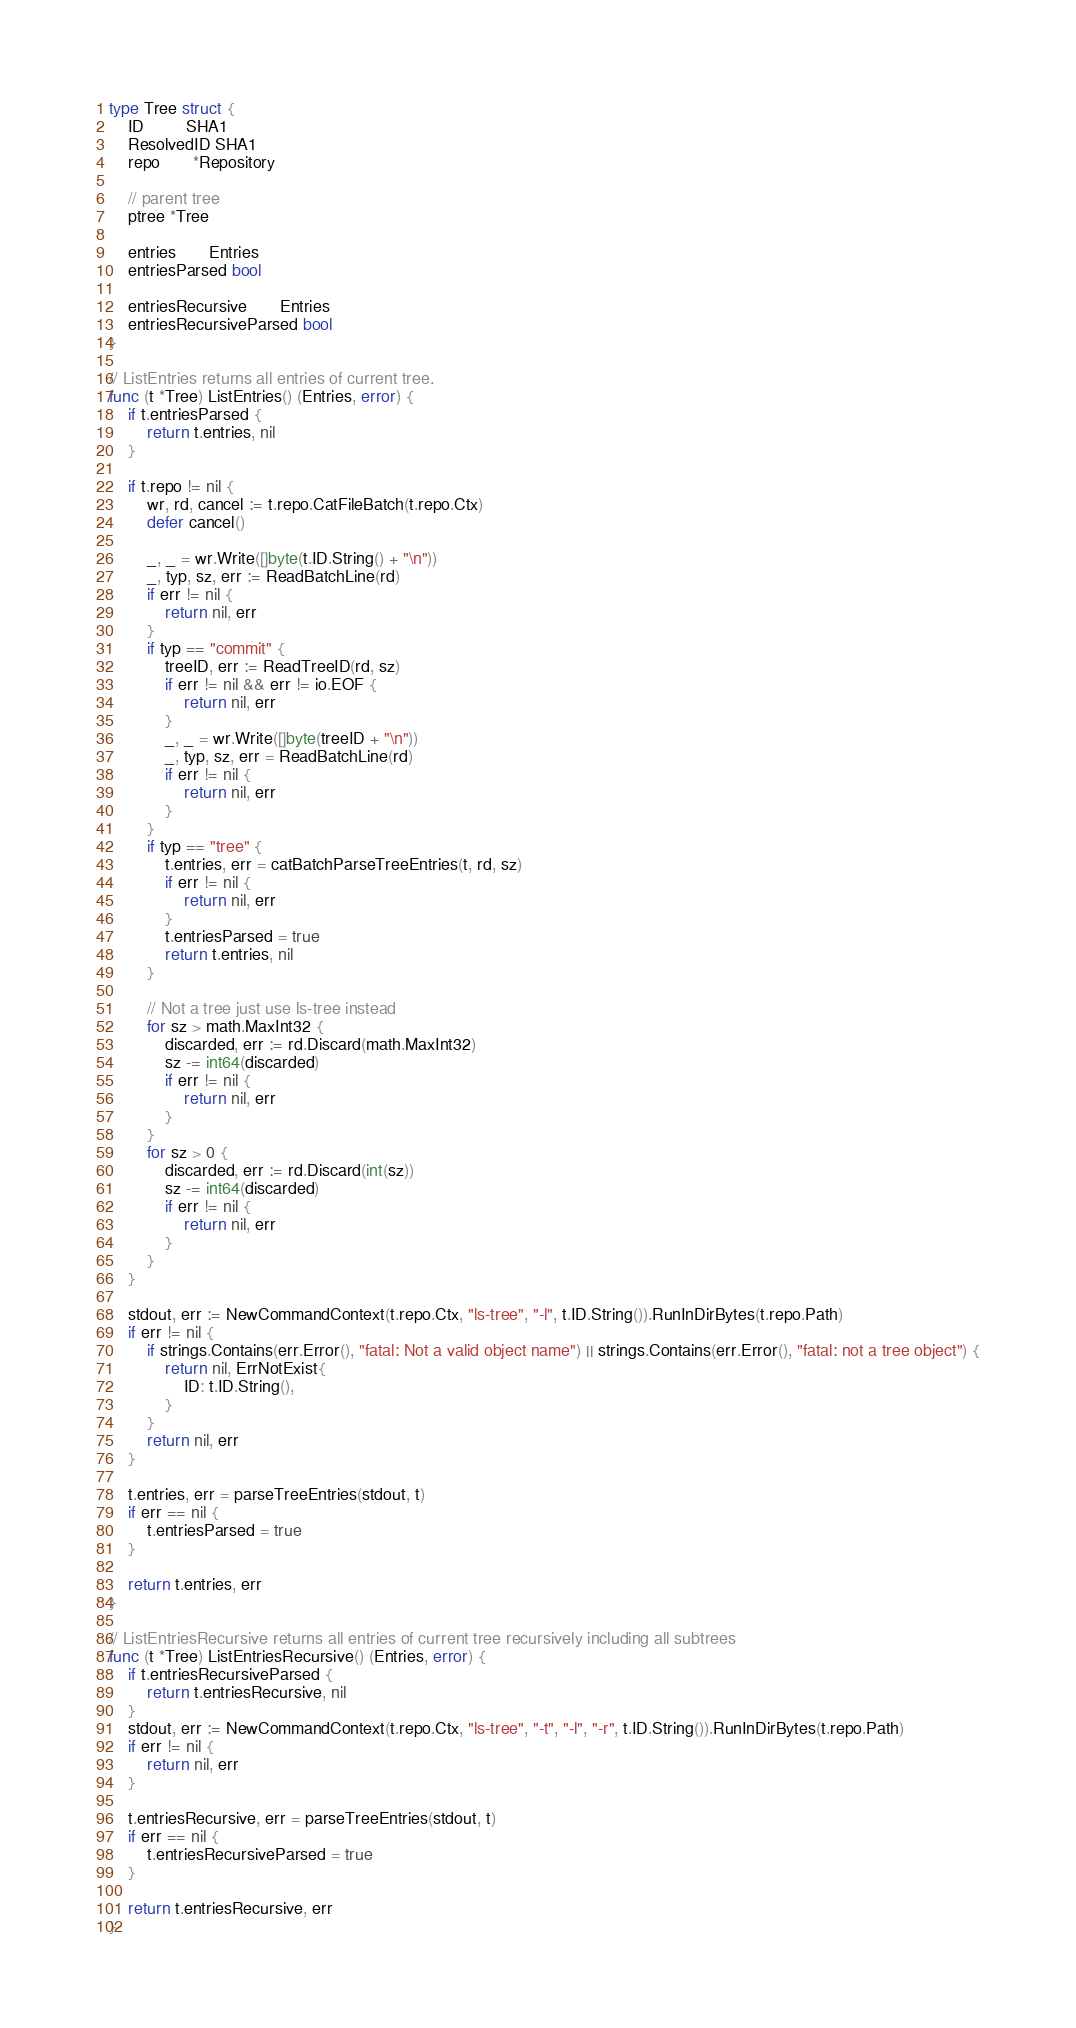Convert code to text. <code><loc_0><loc_0><loc_500><loc_500><_Go_>type Tree struct {
	ID         SHA1
	ResolvedID SHA1
	repo       *Repository

	// parent tree
	ptree *Tree

	entries       Entries
	entriesParsed bool

	entriesRecursive       Entries
	entriesRecursiveParsed bool
}

// ListEntries returns all entries of current tree.
func (t *Tree) ListEntries() (Entries, error) {
	if t.entriesParsed {
		return t.entries, nil
	}

	if t.repo != nil {
		wr, rd, cancel := t.repo.CatFileBatch(t.repo.Ctx)
		defer cancel()

		_, _ = wr.Write([]byte(t.ID.String() + "\n"))
		_, typ, sz, err := ReadBatchLine(rd)
		if err != nil {
			return nil, err
		}
		if typ == "commit" {
			treeID, err := ReadTreeID(rd, sz)
			if err != nil && err != io.EOF {
				return nil, err
			}
			_, _ = wr.Write([]byte(treeID + "\n"))
			_, typ, sz, err = ReadBatchLine(rd)
			if err != nil {
				return nil, err
			}
		}
		if typ == "tree" {
			t.entries, err = catBatchParseTreeEntries(t, rd, sz)
			if err != nil {
				return nil, err
			}
			t.entriesParsed = true
			return t.entries, nil
		}

		// Not a tree just use ls-tree instead
		for sz > math.MaxInt32 {
			discarded, err := rd.Discard(math.MaxInt32)
			sz -= int64(discarded)
			if err != nil {
				return nil, err
			}
		}
		for sz > 0 {
			discarded, err := rd.Discard(int(sz))
			sz -= int64(discarded)
			if err != nil {
				return nil, err
			}
		}
	}

	stdout, err := NewCommandContext(t.repo.Ctx, "ls-tree", "-l", t.ID.String()).RunInDirBytes(t.repo.Path)
	if err != nil {
		if strings.Contains(err.Error(), "fatal: Not a valid object name") || strings.Contains(err.Error(), "fatal: not a tree object") {
			return nil, ErrNotExist{
				ID: t.ID.String(),
			}
		}
		return nil, err
	}

	t.entries, err = parseTreeEntries(stdout, t)
	if err == nil {
		t.entriesParsed = true
	}

	return t.entries, err
}

// ListEntriesRecursive returns all entries of current tree recursively including all subtrees
func (t *Tree) ListEntriesRecursive() (Entries, error) {
	if t.entriesRecursiveParsed {
		return t.entriesRecursive, nil
	}
	stdout, err := NewCommandContext(t.repo.Ctx, "ls-tree", "-t", "-l", "-r", t.ID.String()).RunInDirBytes(t.repo.Path)
	if err != nil {
		return nil, err
	}

	t.entriesRecursive, err = parseTreeEntries(stdout, t)
	if err == nil {
		t.entriesRecursiveParsed = true
	}

	return t.entriesRecursive, err
}
</code> 